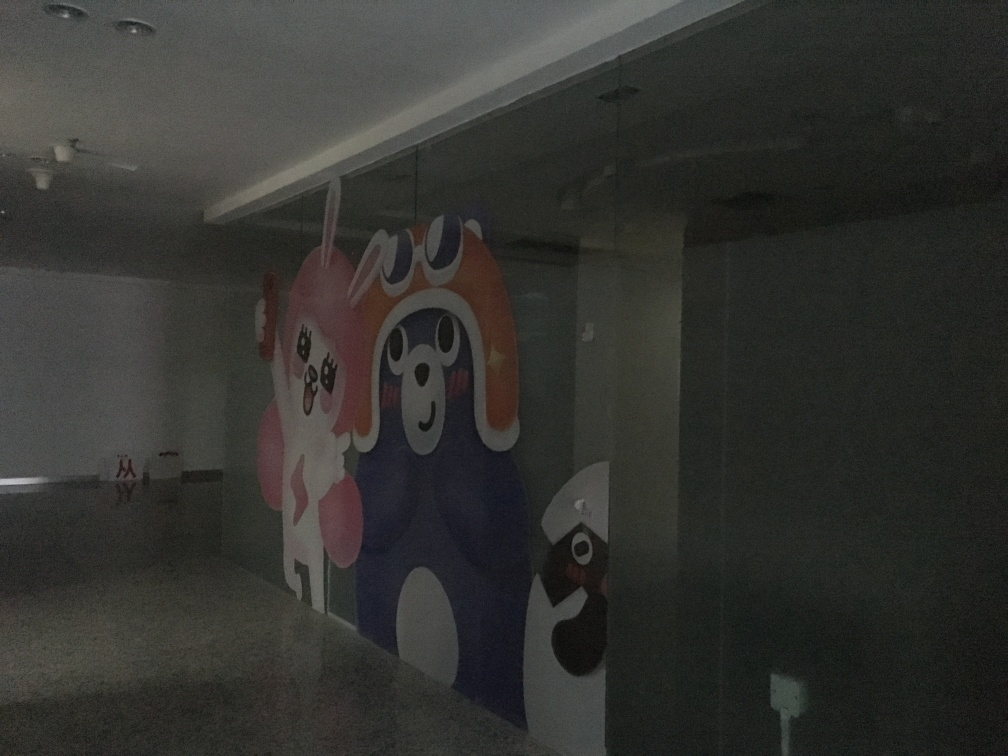Is the lighting adequate in this image? Although some light sources are visible in the image, it is apparent that the overall lighting is not sufficient to illuminate the space effectively, making it challenging to discern finer details. The room could benefit from additional or stronger lighting to enhance visibility, particularly because there is artwork or decor on the wall that appears to be of interest but is lost in the dimness. 